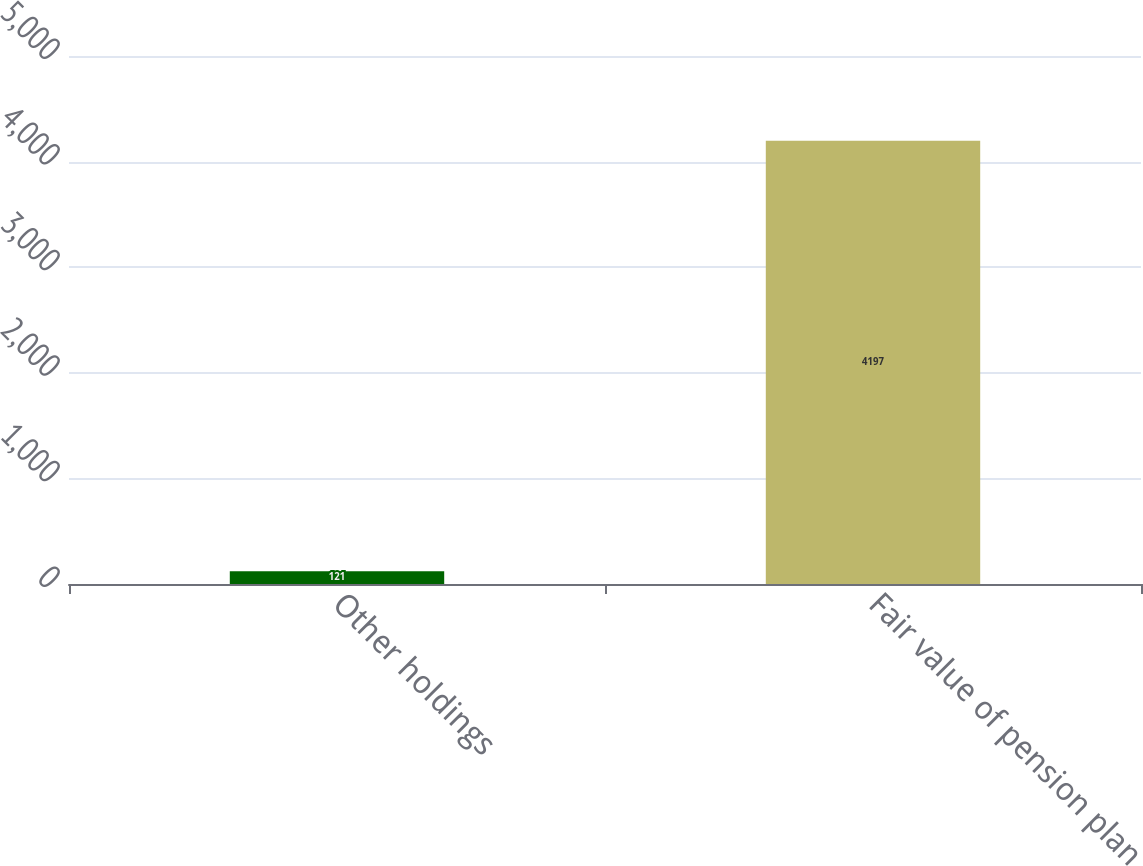<chart> <loc_0><loc_0><loc_500><loc_500><bar_chart><fcel>Other holdings<fcel>Fair value of pension plan<nl><fcel>121<fcel>4197<nl></chart> 